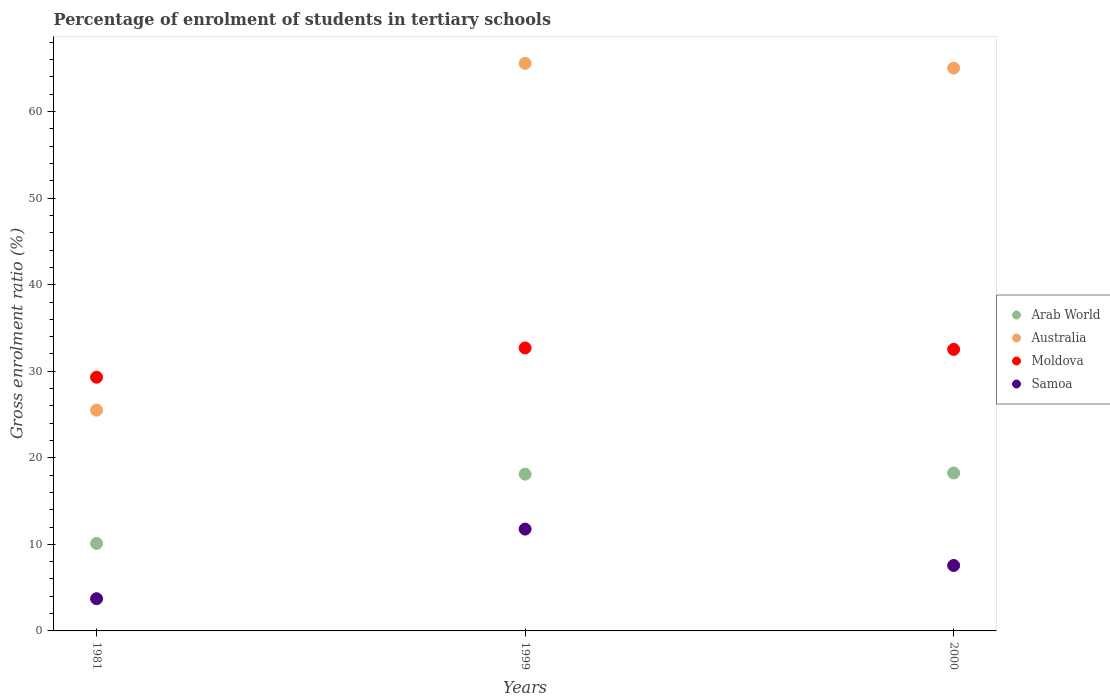Is the number of dotlines equal to the number of legend labels?
Keep it short and to the point. Yes. What is the percentage of students enrolled in tertiary schools in Moldova in 1999?
Ensure brevity in your answer.  32.69. Across all years, what is the maximum percentage of students enrolled in tertiary schools in Moldova?
Give a very brief answer. 32.69. Across all years, what is the minimum percentage of students enrolled in tertiary schools in Samoa?
Offer a very short reply. 3.72. In which year was the percentage of students enrolled in tertiary schools in Arab World minimum?
Provide a short and direct response. 1981. What is the total percentage of students enrolled in tertiary schools in Samoa in the graph?
Ensure brevity in your answer.  23.05. What is the difference between the percentage of students enrolled in tertiary schools in Samoa in 1981 and that in 1999?
Your answer should be very brief. -8.04. What is the difference between the percentage of students enrolled in tertiary schools in Moldova in 1981 and the percentage of students enrolled in tertiary schools in Samoa in 1999?
Offer a terse response. 17.55. What is the average percentage of students enrolled in tertiary schools in Moldova per year?
Your answer should be very brief. 31.51. In the year 1999, what is the difference between the percentage of students enrolled in tertiary schools in Moldova and percentage of students enrolled in tertiary schools in Arab World?
Your response must be concise. 14.58. What is the ratio of the percentage of students enrolled in tertiary schools in Australia in 1981 to that in 1999?
Make the answer very short. 0.39. Is the percentage of students enrolled in tertiary schools in Samoa in 1981 less than that in 1999?
Your response must be concise. Yes. What is the difference between the highest and the second highest percentage of students enrolled in tertiary schools in Samoa?
Give a very brief answer. 4.2. What is the difference between the highest and the lowest percentage of students enrolled in tertiary schools in Australia?
Give a very brief answer. 40.07. In how many years, is the percentage of students enrolled in tertiary schools in Samoa greater than the average percentage of students enrolled in tertiary schools in Samoa taken over all years?
Your answer should be compact. 1. Is it the case that in every year, the sum of the percentage of students enrolled in tertiary schools in Moldova and percentage of students enrolled in tertiary schools in Australia  is greater than the sum of percentage of students enrolled in tertiary schools in Samoa and percentage of students enrolled in tertiary schools in Arab World?
Offer a very short reply. Yes. Does the percentage of students enrolled in tertiary schools in Samoa monotonically increase over the years?
Give a very brief answer. No. How many dotlines are there?
Offer a very short reply. 4. How many years are there in the graph?
Offer a very short reply. 3. Are the values on the major ticks of Y-axis written in scientific E-notation?
Your response must be concise. No. How many legend labels are there?
Make the answer very short. 4. What is the title of the graph?
Give a very brief answer. Percentage of enrolment of students in tertiary schools. Does "Nigeria" appear as one of the legend labels in the graph?
Your response must be concise. No. What is the label or title of the X-axis?
Provide a succinct answer. Years. What is the label or title of the Y-axis?
Give a very brief answer. Gross enrolment ratio (%). What is the Gross enrolment ratio (%) in Arab World in 1981?
Your answer should be very brief. 10.11. What is the Gross enrolment ratio (%) in Australia in 1981?
Your answer should be compact. 25.51. What is the Gross enrolment ratio (%) of Moldova in 1981?
Make the answer very short. 29.31. What is the Gross enrolment ratio (%) in Samoa in 1981?
Your answer should be compact. 3.72. What is the Gross enrolment ratio (%) in Arab World in 1999?
Your response must be concise. 18.11. What is the Gross enrolment ratio (%) of Australia in 1999?
Provide a succinct answer. 65.58. What is the Gross enrolment ratio (%) of Moldova in 1999?
Ensure brevity in your answer.  32.69. What is the Gross enrolment ratio (%) of Samoa in 1999?
Provide a succinct answer. 11.76. What is the Gross enrolment ratio (%) in Arab World in 2000?
Your answer should be compact. 18.25. What is the Gross enrolment ratio (%) of Australia in 2000?
Provide a succinct answer. 65.03. What is the Gross enrolment ratio (%) in Moldova in 2000?
Make the answer very short. 32.53. What is the Gross enrolment ratio (%) in Samoa in 2000?
Your answer should be compact. 7.56. Across all years, what is the maximum Gross enrolment ratio (%) of Arab World?
Your answer should be compact. 18.25. Across all years, what is the maximum Gross enrolment ratio (%) of Australia?
Your answer should be compact. 65.58. Across all years, what is the maximum Gross enrolment ratio (%) in Moldova?
Make the answer very short. 32.69. Across all years, what is the maximum Gross enrolment ratio (%) in Samoa?
Provide a succinct answer. 11.76. Across all years, what is the minimum Gross enrolment ratio (%) of Arab World?
Give a very brief answer. 10.11. Across all years, what is the minimum Gross enrolment ratio (%) in Australia?
Ensure brevity in your answer.  25.51. Across all years, what is the minimum Gross enrolment ratio (%) of Moldova?
Your response must be concise. 29.31. Across all years, what is the minimum Gross enrolment ratio (%) of Samoa?
Offer a very short reply. 3.72. What is the total Gross enrolment ratio (%) of Arab World in the graph?
Keep it short and to the point. 46.48. What is the total Gross enrolment ratio (%) of Australia in the graph?
Your answer should be very brief. 156.11. What is the total Gross enrolment ratio (%) of Moldova in the graph?
Keep it short and to the point. 94.53. What is the total Gross enrolment ratio (%) of Samoa in the graph?
Give a very brief answer. 23.05. What is the difference between the Gross enrolment ratio (%) in Arab World in 1981 and that in 1999?
Your answer should be very brief. -8. What is the difference between the Gross enrolment ratio (%) of Australia in 1981 and that in 1999?
Provide a succinct answer. -40.07. What is the difference between the Gross enrolment ratio (%) in Moldova in 1981 and that in 1999?
Your answer should be very brief. -3.39. What is the difference between the Gross enrolment ratio (%) of Samoa in 1981 and that in 1999?
Ensure brevity in your answer.  -8.04. What is the difference between the Gross enrolment ratio (%) in Arab World in 1981 and that in 2000?
Provide a succinct answer. -8.14. What is the difference between the Gross enrolment ratio (%) in Australia in 1981 and that in 2000?
Give a very brief answer. -39.52. What is the difference between the Gross enrolment ratio (%) of Moldova in 1981 and that in 2000?
Keep it short and to the point. -3.22. What is the difference between the Gross enrolment ratio (%) in Samoa in 1981 and that in 2000?
Offer a terse response. -3.84. What is the difference between the Gross enrolment ratio (%) in Arab World in 1999 and that in 2000?
Keep it short and to the point. -0.14. What is the difference between the Gross enrolment ratio (%) in Australia in 1999 and that in 2000?
Provide a succinct answer. 0.55. What is the difference between the Gross enrolment ratio (%) in Moldova in 1999 and that in 2000?
Keep it short and to the point. 0.17. What is the difference between the Gross enrolment ratio (%) of Samoa in 1999 and that in 2000?
Ensure brevity in your answer.  4.2. What is the difference between the Gross enrolment ratio (%) in Arab World in 1981 and the Gross enrolment ratio (%) in Australia in 1999?
Provide a short and direct response. -55.46. What is the difference between the Gross enrolment ratio (%) in Arab World in 1981 and the Gross enrolment ratio (%) in Moldova in 1999?
Provide a succinct answer. -22.58. What is the difference between the Gross enrolment ratio (%) in Arab World in 1981 and the Gross enrolment ratio (%) in Samoa in 1999?
Offer a very short reply. -1.65. What is the difference between the Gross enrolment ratio (%) in Australia in 1981 and the Gross enrolment ratio (%) in Moldova in 1999?
Offer a very short reply. -7.19. What is the difference between the Gross enrolment ratio (%) in Australia in 1981 and the Gross enrolment ratio (%) in Samoa in 1999?
Give a very brief answer. 13.74. What is the difference between the Gross enrolment ratio (%) of Moldova in 1981 and the Gross enrolment ratio (%) of Samoa in 1999?
Provide a succinct answer. 17.55. What is the difference between the Gross enrolment ratio (%) of Arab World in 1981 and the Gross enrolment ratio (%) of Australia in 2000?
Provide a succinct answer. -54.91. What is the difference between the Gross enrolment ratio (%) of Arab World in 1981 and the Gross enrolment ratio (%) of Moldova in 2000?
Ensure brevity in your answer.  -22.42. What is the difference between the Gross enrolment ratio (%) in Arab World in 1981 and the Gross enrolment ratio (%) in Samoa in 2000?
Offer a terse response. 2.55. What is the difference between the Gross enrolment ratio (%) in Australia in 1981 and the Gross enrolment ratio (%) in Moldova in 2000?
Your answer should be very brief. -7.02. What is the difference between the Gross enrolment ratio (%) in Australia in 1981 and the Gross enrolment ratio (%) in Samoa in 2000?
Give a very brief answer. 17.94. What is the difference between the Gross enrolment ratio (%) in Moldova in 1981 and the Gross enrolment ratio (%) in Samoa in 2000?
Offer a very short reply. 21.75. What is the difference between the Gross enrolment ratio (%) in Arab World in 1999 and the Gross enrolment ratio (%) in Australia in 2000?
Ensure brevity in your answer.  -46.91. What is the difference between the Gross enrolment ratio (%) of Arab World in 1999 and the Gross enrolment ratio (%) of Moldova in 2000?
Provide a succinct answer. -14.42. What is the difference between the Gross enrolment ratio (%) of Arab World in 1999 and the Gross enrolment ratio (%) of Samoa in 2000?
Your answer should be compact. 10.55. What is the difference between the Gross enrolment ratio (%) of Australia in 1999 and the Gross enrolment ratio (%) of Moldova in 2000?
Make the answer very short. 33.05. What is the difference between the Gross enrolment ratio (%) in Australia in 1999 and the Gross enrolment ratio (%) in Samoa in 2000?
Offer a terse response. 58.01. What is the difference between the Gross enrolment ratio (%) of Moldova in 1999 and the Gross enrolment ratio (%) of Samoa in 2000?
Ensure brevity in your answer.  25.13. What is the average Gross enrolment ratio (%) in Arab World per year?
Your response must be concise. 15.49. What is the average Gross enrolment ratio (%) in Australia per year?
Provide a short and direct response. 52.04. What is the average Gross enrolment ratio (%) of Moldova per year?
Provide a succinct answer. 31.51. What is the average Gross enrolment ratio (%) of Samoa per year?
Give a very brief answer. 7.68. In the year 1981, what is the difference between the Gross enrolment ratio (%) in Arab World and Gross enrolment ratio (%) in Australia?
Offer a very short reply. -15.39. In the year 1981, what is the difference between the Gross enrolment ratio (%) of Arab World and Gross enrolment ratio (%) of Moldova?
Your response must be concise. -19.2. In the year 1981, what is the difference between the Gross enrolment ratio (%) of Arab World and Gross enrolment ratio (%) of Samoa?
Your response must be concise. 6.39. In the year 1981, what is the difference between the Gross enrolment ratio (%) of Australia and Gross enrolment ratio (%) of Moldova?
Your response must be concise. -3.8. In the year 1981, what is the difference between the Gross enrolment ratio (%) in Australia and Gross enrolment ratio (%) in Samoa?
Ensure brevity in your answer.  21.78. In the year 1981, what is the difference between the Gross enrolment ratio (%) of Moldova and Gross enrolment ratio (%) of Samoa?
Provide a short and direct response. 25.59. In the year 1999, what is the difference between the Gross enrolment ratio (%) of Arab World and Gross enrolment ratio (%) of Australia?
Make the answer very short. -47.46. In the year 1999, what is the difference between the Gross enrolment ratio (%) of Arab World and Gross enrolment ratio (%) of Moldova?
Give a very brief answer. -14.58. In the year 1999, what is the difference between the Gross enrolment ratio (%) of Arab World and Gross enrolment ratio (%) of Samoa?
Your answer should be very brief. 6.35. In the year 1999, what is the difference between the Gross enrolment ratio (%) in Australia and Gross enrolment ratio (%) in Moldova?
Offer a terse response. 32.88. In the year 1999, what is the difference between the Gross enrolment ratio (%) of Australia and Gross enrolment ratio (%) of Samoa?
Offer a terse response. 53.81. In the year 1999, what is the difference between the Gross enrolment ratio (%) of Moldova and Gross enrolment ratio (%) of Samoa?
Offer a terse response. 20.93. In the year 2000, what is the difference between the Gross enrolment ratio (%) in Arab World and Gross enrolment ratio (%) in Australia?
Give a very brief answer. -46.78. In the year 2000, what is the difference between the Gross enrolment ratio (%) in Arab World and Gross enrolment ratio (%) in Moldova?
Give a very brief answer. -14.28. In the year 2000, what is the difference between the Gross enrolment ratio (%) of Arab World and Gross enrolment ratio (%) of Samoa?
Keep it short and to the point. 10.69. In the year 2000, what is the difference between the Gross enrolment ratio (%) in Australia and Gross enrolment ratio (%) in Moldova?
Your answer should be compact. 32.5. In the year 2000, what is the difference between the Gross enrolment ratio (%) of Australia and Gross enrolment ratio (%) of Samoa?
Ensure brevity in your answer.  57.46. In the year 2000, what is the difference between the Gross enrolment ratio (%) in Moldova and Gross enrolment ratio (%) in Samoa?
Provide a succinct answer. 24.97. What is the ratio of the Gross enrolment ratio (%) of Arab World in 1981 to that in 1999?
Offer a terse response. 0.56. What is the ratio of the Gross enrolment ratio (%) in Australia in 1981 to that in 1999?
Keep it short and to the point. 0.39. What is the ratio of the Gross enrolment ratio (%) of Moldova in 1981 to that in 1999?
Give a very brief answer. 0.9. What is the ratio of the Gross enrolment ratio (%) of Samoa in 1981 to that in 1999?
Your answer should be compact. 0.32. What is the ratio of the Gross enrolment ratio (%) in Arab World in 1981 to that in 2000?
Provide a short and direct response. 0.55. What is the ratio of the Gross enrolment ratio (%) of Australia in 1981 to that in 2000?
Your answer should be compact. 0.39. What is the ratio of the Gross enrolment ratio (%) of Moldova in 1981 to that in 2000?
Your answer should be very brief. 0.9. What is the ratio of the Gross enrolment ratio (%) in Samoa in 1981 to that in 2000?
Your answer should be compact. 0.49. What is the ratio of the Gross enrolment ratio (%) in Australia in 1999 to that in 2000?
Offer a very short reply. 1.01. What is the ratio of the Gross enrolment ratio (%) in Samoa in 1999 to that in 2000?
Keep it short and to the point. 1.56. What is the difference between the highest and the second highest Gross enrolment ratio (%) in Arab World?
Your response must be concise. 0.14. What is the difference between the highest and the second highest Gross enrolment ratio (%) of Australia?
Provide a succinct answer. 0.55. What is the difference between the highest and the second highest Gross enrolment ratio (%) in Moldova?
Offer a very short reply. 0.17. What is the difference between the highest and the second highest Gross enrolment ratio (%) in Samoa?
Your answer should be compact. 4.2. What is the difference between the highest and the lowest Gross enrolment ratio (%) of Arab World?
Provide a succinct answer. 8.14. What is the difference between the highest and the lowest Gross enrolment ratio (%) of Australia?
Ensure brevity in your answer.  40.07. What is the difference between the highest and the lowest Gross enrolment ratio (%) of Moldova?
Your answer should be very brief. 3.39. What is the difference between the highest and the lowest Gross enrolment ratio (%) of Samoa?
Your response must be concise. 8.04. 